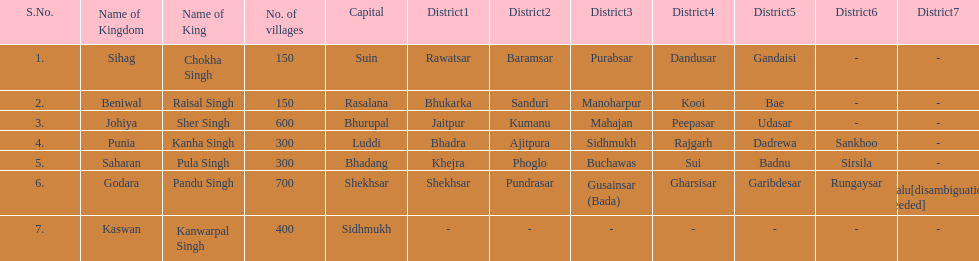Does punia have more or less villages than godara? Less. 